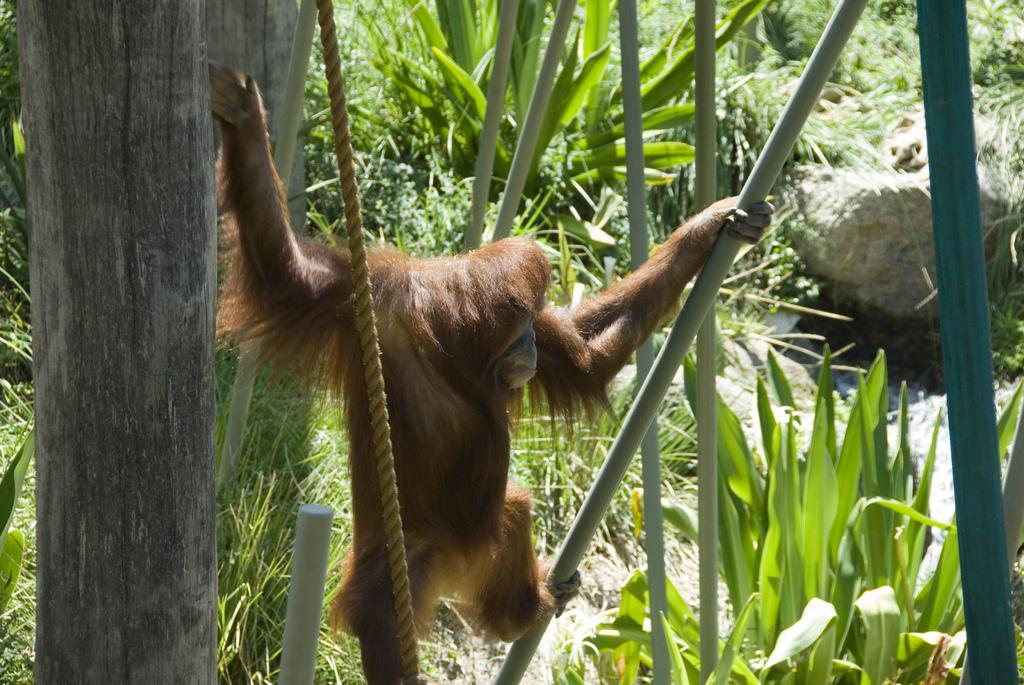What animal is present in the image? There is a monkey in the image. What is the monkey holding in the image? The monkey is holding a stick. What object is in front of the monkey? There is a rope in front of the monkey. What type of environment is depicted in the image? There are trees and plants around the monkey, suggesting a natural setting. How can you tell if the monkey is being quiet in the image? There is no indication of the monkey's noise level in the image, so it cannot be determined whether the monkey is being quiet or not. 